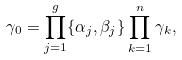<formula> <loc_0><loc_0><loc_500><loc_500>\gamma _ { 0 } = \prod _ { j = 1 } ^ { g } \{ \alpha _ { j } , \beta _ { j } \} \prod _ { k = 1 } ^ { n } \gamma _ { k } ,</formula> 